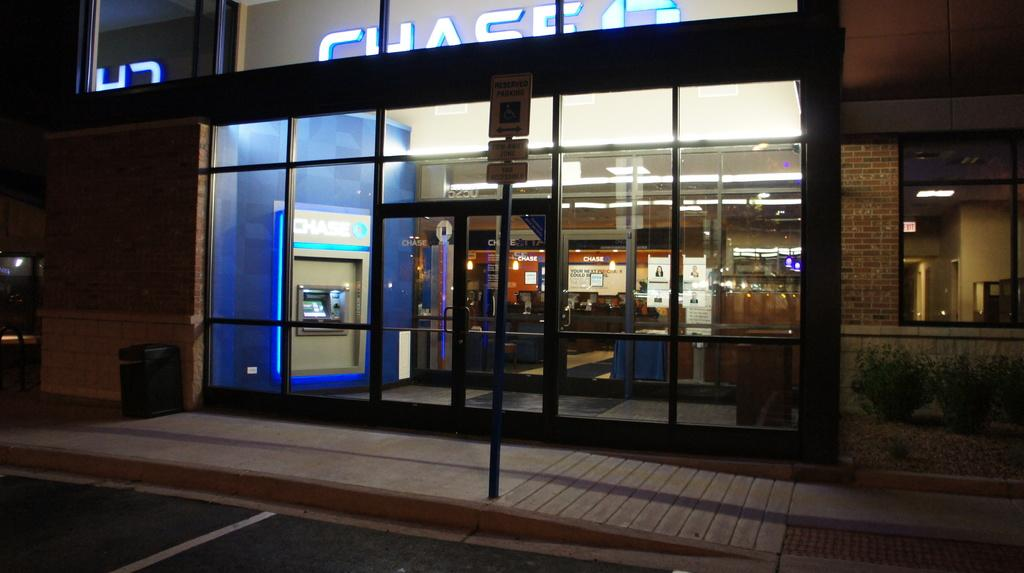<image>
Write a terse but informative summary of the picture. a building that has the word Chase on it 